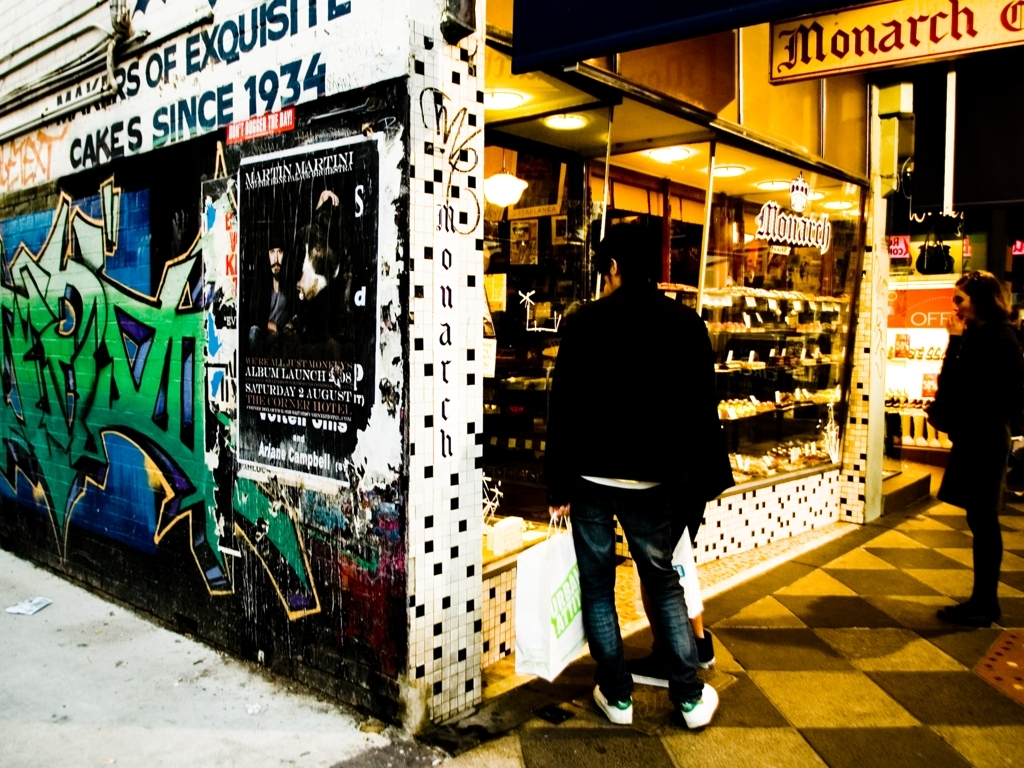What can you tell me about the setting of this photo? The image captures an urban night scene likely outside a bakery or cake shop, as indicated by the signage 'Monarch Cakes.' The environment suggests a bustling city atmosphere with a rich cultural vibe, underscored by vivid street art which introduces a contrast between the shop's traditional appeal and the modern, expressive graffiti. 